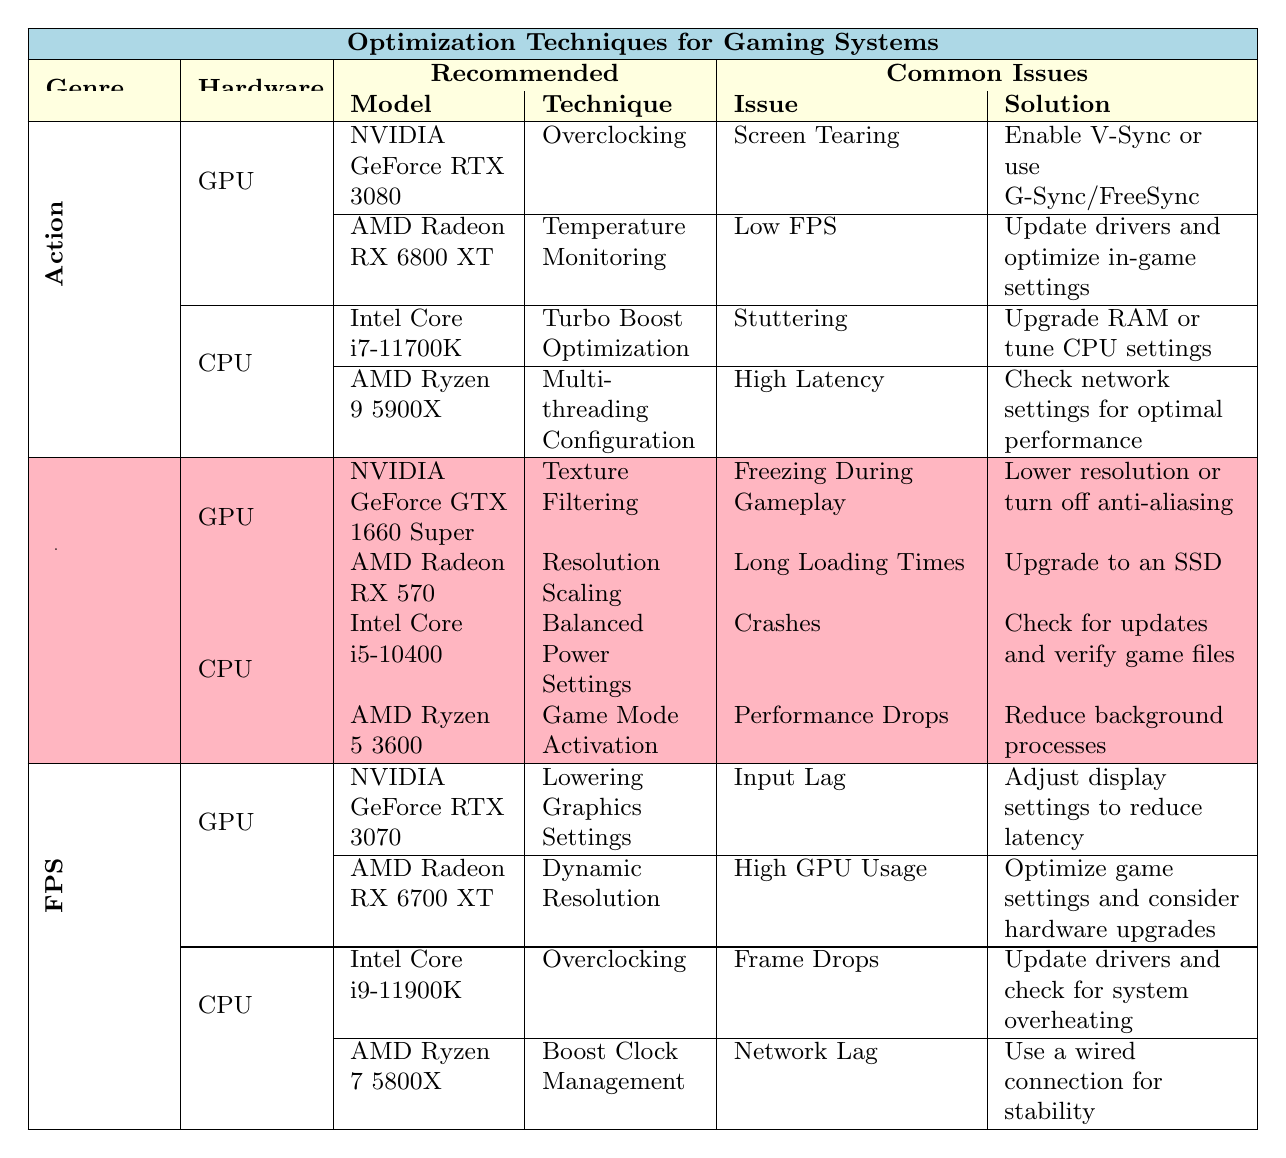What optimization technique is recommended for NVIDIA GeForce RTX 3080? The table shows that for the NVIDIA GeForce RTX 3080, the recommended technique is "Overclocking."
Answer: Overclocking What is a common issue faced by RPG GPU users related to freezing? According to the table, the common issue is "Freezing During Gameplay," and the recommended solution is to lower the resolution or turn off anti-aliasing.
Answer: Freezing During Gameplay Which CPU is suggested for FPS games to manage boost clock? The table indicates that the AMD Ryzen 7 5800X is recommended for FPS games with the technique of "Boost Clock Management."
Answer: AMD Ryzen 7 5800X What is the recommended solution for high GPU usage in FPS games? The recommended solution for high GPU usage is to optimize game settings and consider hardware upgrades.
Answer: Optimize game settings and consider hardware upgrades How many optimization techniques are listed for Action genre CPUs? The table provides two recommended techniques for Action genre CPUs: "Turbo Boost Optimization" for Intel Core i7-11700K and "Multi-threading Configuration" for AMD Ryzen 9 5900X. Therefore, there are 2 techniques listed.
Answer: 2 Is "Temperature Monitoring" a technique recommended for RPG GPUs? No, "Temperature Monitoring" is not listed under RPG GPUs. It is recommended for Action GPUs (AMD Radeon RX 6800 XT).
Answer: No What is the technique associated with the AMD Radeon RX 570 for RPG? The technique associated with the AMD Radeon RX 570 for RPG is "Resolution Scaling."
Answer: Resolution Scaling Which hardware component has more common issues listed, GPU or CPU in Action genre? In the Action genre, the CPU has 2 common issues listed (Stuttering and High Latency) while the GPU also has 2 common issues (Screen Tearing and Low FPS). They both have the same number of common issues.
Answer: Neither, both have 2 issues If a player faces input lag in FPS games, which adjustment should they make? The table suggests adjusting display settings to reduce latency as a solution for input lag in FPS games.
Answer: Adjust display settings to reduce latency Which game genre recommends "Balanced Power Settings" for CPU? The RPG genre recommends "Balanced Power Settings" for the CPU (Intel Core i5-10400).
Answer: RPG 